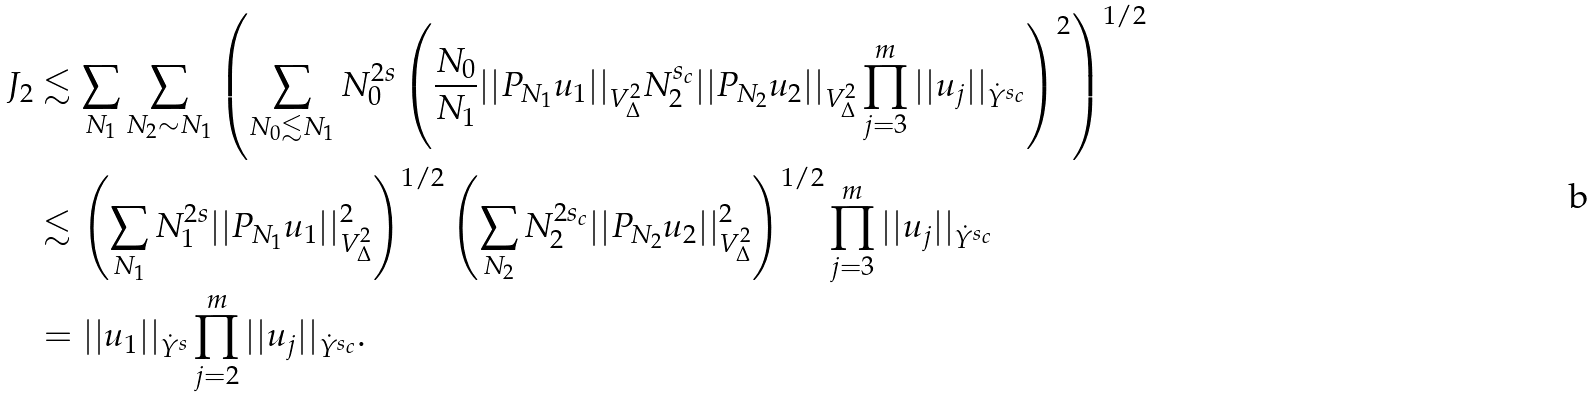Convert formula to latex. <formula><loc_0><loc_0><loc_500><loc_500>J _ { 2 } & \lesssim \sum _ { N _ { 1 } } \sum _ { N _ { 2 } \sim N _ { 1 } } \left ( \sum _ { N _ { 0 } \lesssim N _ { 1 } } N _ { 0 } ^ { 2 s } \left ( \frac { N _ { 0 } } { N _ { 1 } } | | P _ { N _ { 1 } } u _ { 1 } | | _ { V ^ { 2 } _ { \Delta } } N _ { 2 } ^ { s _ { c } } | | P _ { N _ { 2 } } u _ { 2 } | | _ { V ^ { 2 } _ { \Delta } } \prod _ { j = 3 } ^ { m } | | u _ { j } | | _ { \dot { Y } ^ { s _ { c } } } \right ) ^ { 2 } \right ) ^ { 1 / 2 } \\ & \lesssim \left ( \sum _ { N _ { 1 } } N _ { 1 } ^ { 2 s } | | P _ { N _ { 1 } } u _ { 1 } | | _ { V ^ { 2 } _ { \Delta } } ^ { 2 } \right ) ^ { 1 / 2 } \left ( \sum _ { N _ { 2 } } N _ { 2 } ^ { 2 s _ { c } } | | P _ { N _ { 2 } } u _ { 2 } | | _ { V ^ { 2 } _ { \Delta } } ^ { 2 } \right ) ^ { 1 / 2 } \prod _ { j = 3 } ^ { m } | | u _ { j } | | _ { \dot { Y } ^ { s _ { c } } } \\ & = | | u _ { 1 } | | _ { \dot { Y } ^ { s } } \prod _ { j = 2 } ^ { m } | | u _ { j } | | _ { \dot { Y } ^ { s _ { c } } } .</formula> 